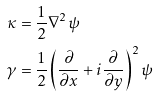<formula> <loc_0><loc_0><loc_500><loc_500>\kappa & = \frac { 1 } { 2 } \nabla ^ { 2 } \psi \\ \gamma & = \frac { 1 } { 2 } \left ( \frac { \partial } { \partial x } + i \frac { \partial } { \partial y } \right ) ^ { 2 } \psi</formula> 